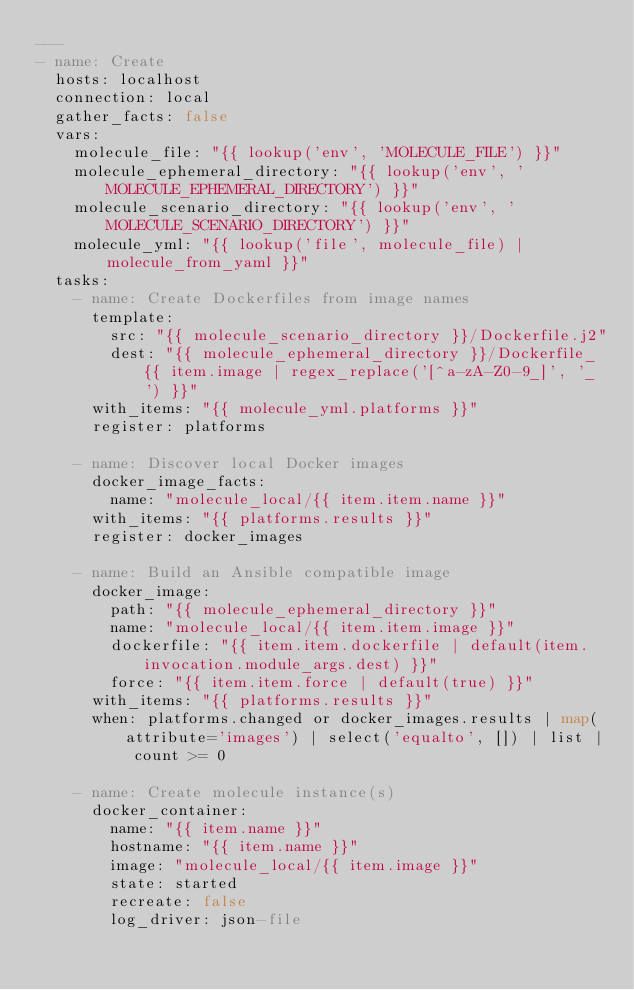<code> <loc_0><loc_0><loc_500><loc_500><_YAML_>---
- name: Create
  hosts: localhost
  connection: local
  gather_facts: false
  vars:
    molecule_file: "{{ lookup('env', 'MOLECULE_FILE') }}"
    molecule_ephemeral_directory: "{{ lookup('env', 'MOLECULE_EPHEMERAL_DIRECTORY') }}"
    molecule_scenario_directory: "{{ lookup('env', 'MOLECULE_SCENARIO_DIRECTORY') }}"
    molecule_yml: "{{ lookup('file', molecule_file) | molecule_from_yaml }}"
  tasks:
    - name: Create Dockerfiles from image names
      template:
        src: "{{ molecule_scenario_directory }}/Dockerfile.j2"
        dest: "{{ molecule_ephemeral_directory }}/Dockerfile_{{ item.image | regex_replace('[^a-zA-Z0-9_]', '_') }}"
      with_items: "{{ molecule_yml.platforms }}"
      register: platforms

    - name: Discover local Docker images
      docker_image_facts:
        name: "molecule_local/{{ item.item.name }}"
      with_items: "{{ platforms.results }}"
      register: docker_images

    - name: Build an Ansible compatible image
      docker_image:
        path: "{{ molecule_ephemeral_directory }}"
        name: "molecule_local/{{ item.item.image }}"
        dockerfile: "{{ item.item.dockerfile | default(item.invocation.module_args.dest) }}"
        force: "{{ item.item.force | default(true) }}"
      with_items: "{{ platforms.results }}"
      when: platforms.changed or docker_images.results | map(attribute='images') | select('equalto', []) | list | count >= 0

    - name: Create molecule instance(s)
      docker_container:
        name: "{{ item.name }}"
        hostname: "{{ item.name }}"
        image: "molecule_local/{{ item.image }}"
        state: started
        recreate: false
        log_driver: json-file</code> 